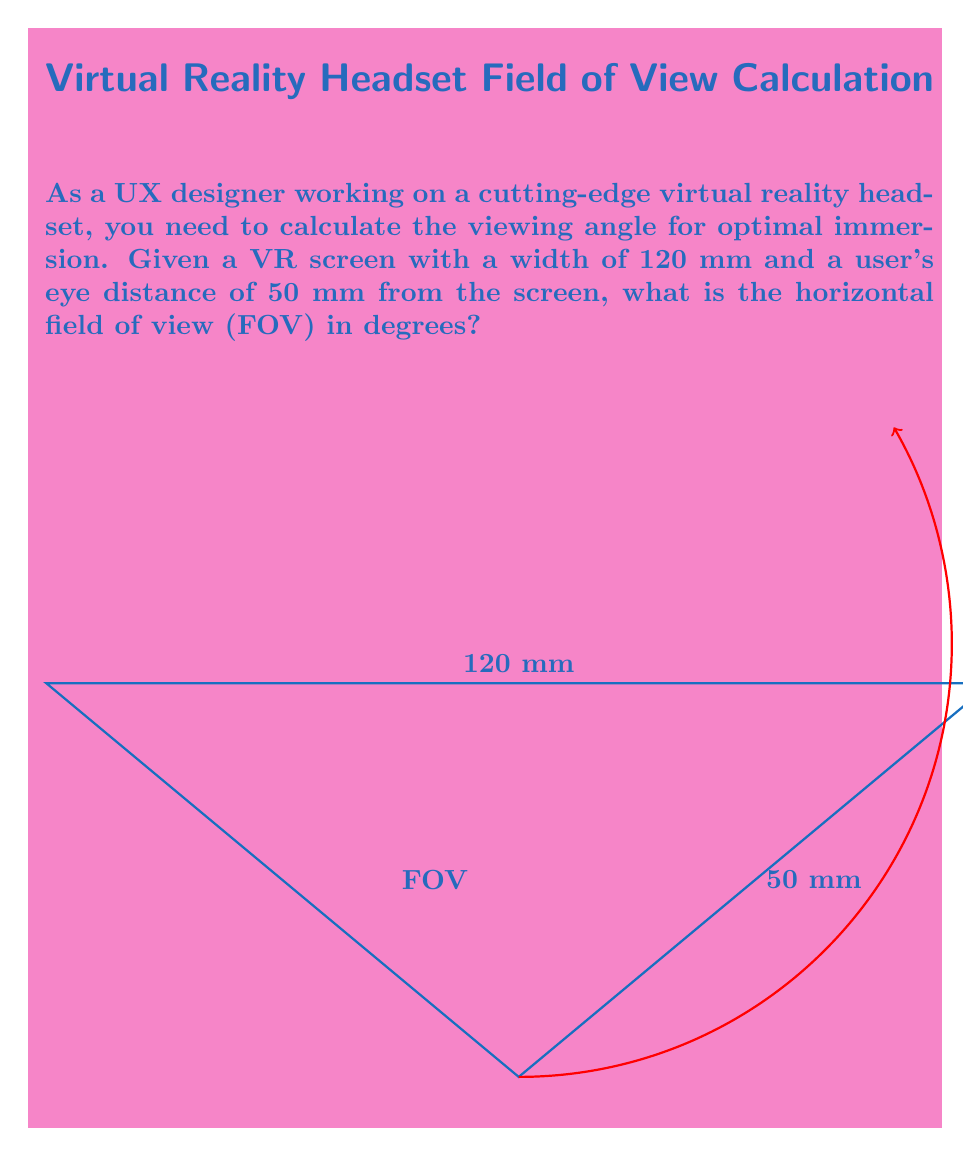Give your solution to this math problem. To calculate the horizontal field of view (FOV) for a VR headset, we can use the following steps:

1) The FOV is twice the angle formed between the center of the screen and one edge. We can calculate this using the tangent function.

2) Half the screen width is 120 mm / 2 = 60 mm.

3) The tangent of half the FOV angle is the ratio of half the screen width to the eye distance:

   $$\tan(\frac{FOV}{2}) = \frac{60}{50}$$

4) To find the FOV, we need to solve for it:

   $$FOV = 2 \cdot \arctan(\frac{60}{50})$$

5) Calculate the arctangent:

   $$FOV = 2 \cdot \arctan(1.2)$$

6) The arctangent of 1.2 is approximately 0.8761 radians.

7) Multiply by 2 and convert to degrees:

   $$FOV = 2 \cdot 0.8761 \cdot \frac{180}{\pi} \approx 100.4°$$

Thus, the horizontal field of view is approximately 100.4 degrees.
Answer: 100.4° 